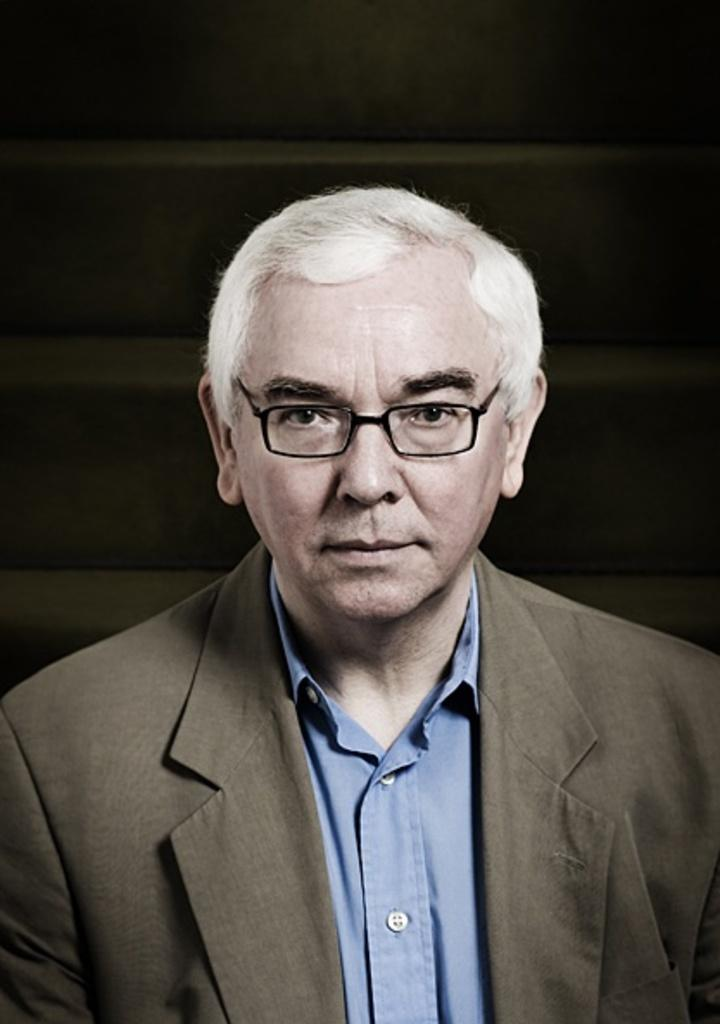Who is present in the image? There is a man in the image. What is the man wearing on his face? The man is wearing spectacles. What type of clothing is the man wearing on his upper body? The man is wearing a blazer and a shirt. What can be seen behind the man in the image? There is a wall behind the man. What type of beef is being served on the plate next to the man in the image? There is no plate or beef present in the image; it only features a man wearing spectacles, a blazer, and a shirt, with a wall behind him. 